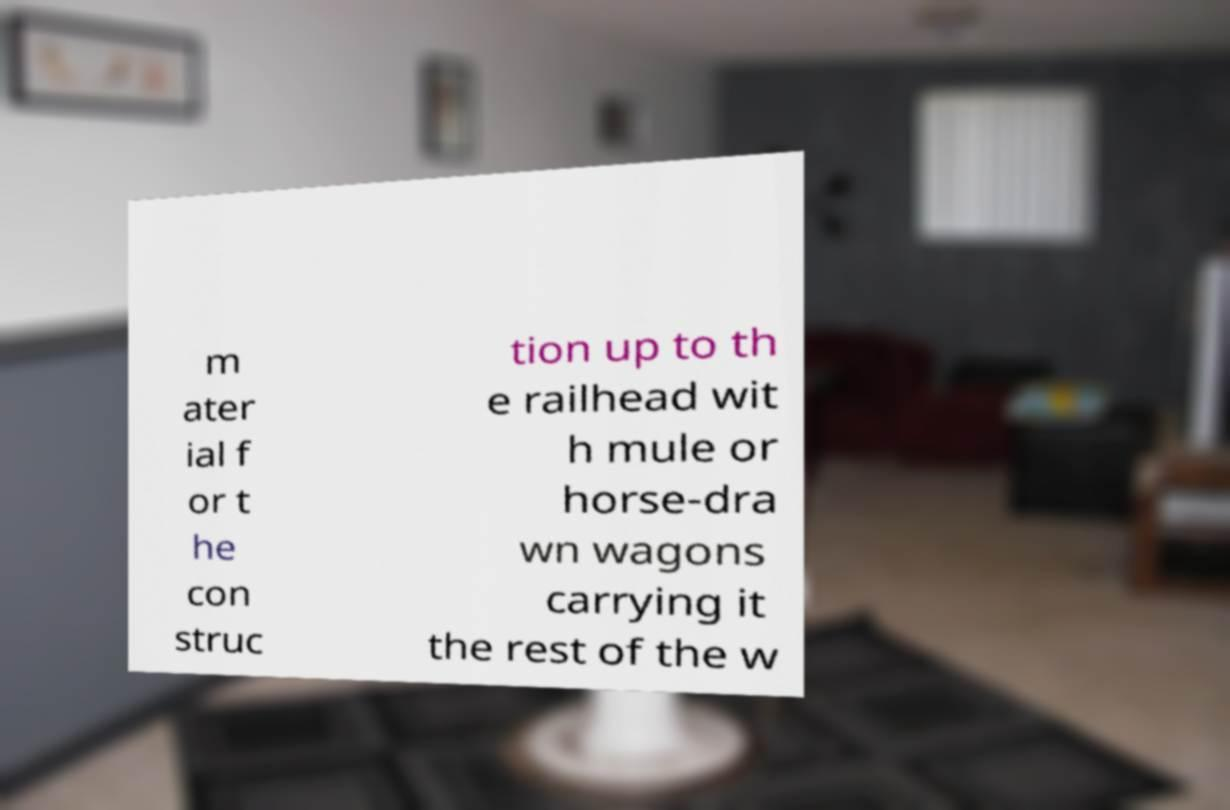There's text embedded in this image that I need extracted. Can you transcribe it verbatim? m ater ial f or t he con struc tion up to th e railhead wit h mule or horse-dra wn wagons carrying it the rest of the w 